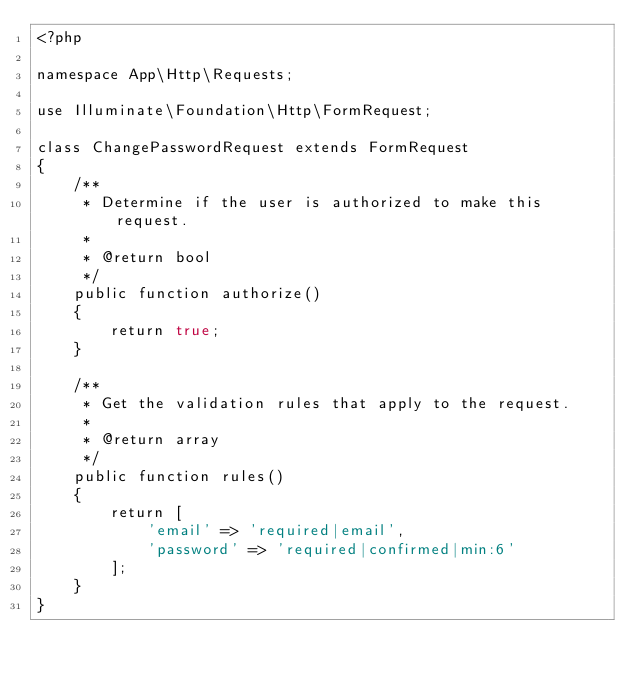Convert code to text. <code><loc_0><loc_0><loc_500><loc_500><_PHP_><?php

namespace App\Http\Requests;

use Illuminate\Foundation\Http\FormRequest;

class ChangePasswordRequest extends FormRequest
{
    /**
     * Determine if the user is authorized to make this request.
     *
     * @return bool
     */
    public function authorize()
    {
        return true;
    }

    /**
     * Get the validation rules that apply to the request.
     *
     * @return array
     */
    public function rules()
    {
        return [
            'email' => 'required|email',
            'password' => 'required|confirmed|min:6'
        ];
    }
}
</code> 